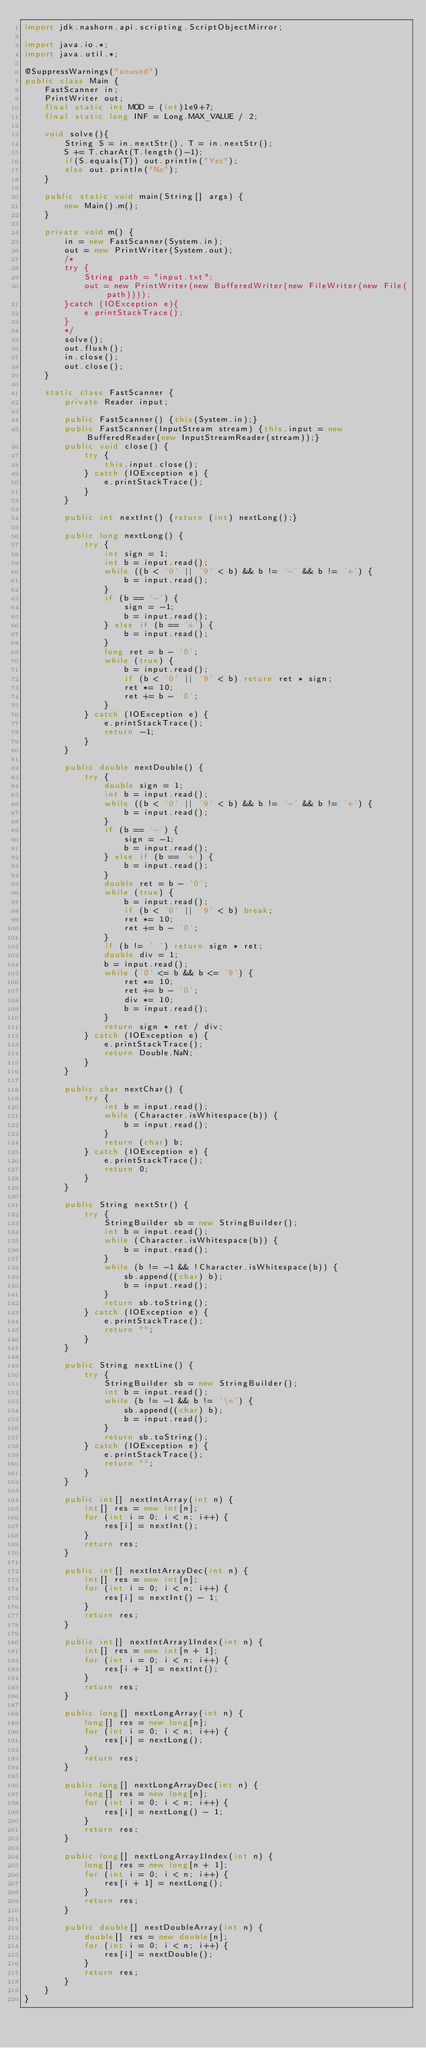Convert code to text. <code><loc_0><loc_0><loc_500><loc_500><_Java_>import jdk.nashorn.api.scripting.ScriptObjectMirror;

import java.io.*;
import java.util.*;

@SuppressWarnings("unused")
public class Main {
    FastScanner in;
    PrintWriter out;
    final static int MOD = (int)1e9+7;
    final static long INF = Long.MAX_VALUE / 2;
    
    void solve(){
        String S = in.nextStr(), T = in.nextStr();
        S += T.charAt(T.length()-1);
        if(S.equals(T)) out.println("Yes");
        else out.println("No");
    }
    
    public static void main(String[] args) {
        new Main().m();
    }
    
    private void m() {
        in = new FastScanner(System.in);
        out = new PrintWriter(System.out);
        /*
        try {
            String path = "input.txt";
            out = new PrintWriter(new BufferedWriter(new FileWriter(new File(path))));
        }catch (IOException e){
            e.printStackTrace();
        }
        */
        solve();
        out.flush();
        in.close();
        out.close();
    }
    
    static class FastScanner {
        private Reader input;
        
        public FastScanner() {this(System.in);}
        public FastScanner(InputStream stream) {this.input = new BufferedReader(new InputStreamReader(stream));}
        public void close() {
            try {
                this.input.close();
            } catch (IOException e) {
                e.printStackTrace();
            }
        }
        
        public int nextInt() {return (int) nextLong();}
        
        public long nextLong() {
            try {
                int sign = 1;
                int b = input.read();
                while ((b < '0' || '9' < b) && b != '-' && b != '+') {
                    b = input.read();
                }
                if (b == '-') {
                    sign = -1;
                    b = input.read();
                } else if (b == '+') {
                    b = input.read();
                }
                long ret = b - '0';
                while (true) {
                    b = input.read();
                    if (b < '0' || '9' < b) return ret * sign;
                    ret *= 10;
                    ret += b - '0';
                }
            } catch (IOException e) {
                e.printStackTrace();
                return -1;
            }
        }
        
        public double nextDouble() {
            try {
                double sign = 1;
                int b = input.read();
                while ((b < '0' || '9' < b) && b != '-' && b != '+') {
                    b = input.read();
                }
                if (b == '-') {
                    sign = -1;
                    b = input.read();
                } else if (b == '+') {
                    b = input.read();
                }
                double ret = b - '0';
                while (true) {
                    b = input.read();
                    if (b < '0' || '9' < b) break;
                    ret *= 10;
                    ret += b - '0';
                }
                if (b != '.') return sign * ret;
                double div = 1;
                b = input.read();
                while ('0' <= b && b <= '9') {
                    ret *= 10;
                    ret += b - '0';
                    div *= 10;
                    b = input.read();
                }
                return sign * ret / div;
            } catch (IOException e) {
                e.printStackTrace();
                return Double.NaN;
            }
        }
        
        public char nextChar() {
            try {
                int b = input.read();
                while (Character.isWhitespace(b)) {
                    b = input.read();
                }
                return (char) b;
            } catch (IOException e) {
                e.printStackTrace();
                return 0;
            }
        }
        
        public String nextStr() {
            try {
                StringBuilder sb = new StringBuilder();
                int b = input.read();
                while (Character.isWhitespace(b)) {
                    b = input.read();
                }
                while (b != -1 && !Character.isWhitespace(b)) {
                    sb.append((char) b);
                    b = input.read();
                }
                return sb.toString();
            } catch (IOException e) {
                e.printStackTrace();
                return "";
            }
        }
        
        public String nextLine() {
            try {
                StringBuilder sb = new StringBuilder();
                int b = input.read();
                while (b != -1 && b != '\n') {
                    sb.append((char) b);
                    b = input.read();
                }
                return sb.toString();
            } catch (IOException e) {
                e.printStackTrace();
                return "";
            }
        }
        
        public int[] nextIntArray(int n) {
            int[] res = new int[n];
            for (int i = 0; i < n; i++) {
                res[i] = nextInt();
            }
            return res;
        }
        
        public int[] nextIntArrayDec(int n) {
            int[] res = new int[n];
            for (int i = 0; i < n; i++) {
                res[i] = nextInt() - 1;
            }
            return res;
        }
        
        public int[] nextIntArray1Index(int n) {
            int[] res = new int[n + 1];
            for (int i = 0; i < n; i++) {
                res[i + 1] = nextInt();
            }
            return res;
        }
        
        public long[] nextLongArray(int n) {
            long[] res = new long[n];
            for (int i = 0; i < n; i++) {
                res[i] = nextLong();
            }
            return res;
        }
        
        public long[] nextLongArrayDec(int n) {
            long[] res = new long[n];
            for (int i = 0; i < n; i++) {
                res[i] = nextLong() - 1;
            }
            return res;
        }
        
        public long[] nextLongArray1Index(int n) {
            long[] res = new long[n + 1];
            for (int i = 0; i < n; i++) {
                res[i + 1] = nextLong();
            }
            return res;
        }
        
        public double[] nextDoubleArray(int n) {
            double[] res = new double[n];
            for (int i = 0; i < n; i++) {
                res[i] = nextDouble();
            }
            return res;
        }
    }
}</code> 